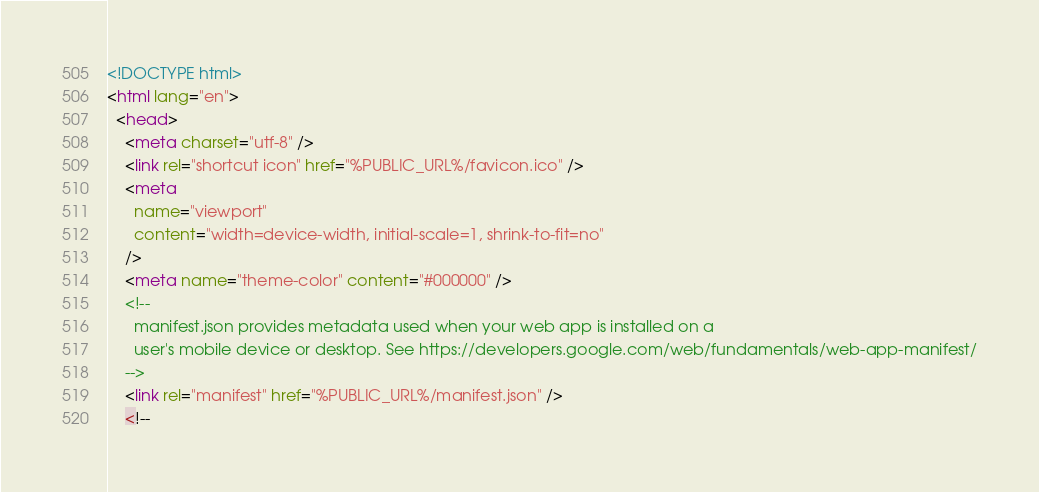<code> <loc_0><loc_0><loc_500><loc_500><_HTML_><!DOCTYPE html>
<html lang="en">
  <head>
    <meta charset="utf-8" />
    <link rel="shortcut icon" href="%PUBLIC_URL%/favicon.ico" />
    <meta
      name="viewport"
      content="width=device-width, initial-scale=1, shrink-to-fit=no"
    />
    <meta name="theme-color" content="#000000" />
    <!--
      manifest.json provides metadata used when your web app is installed on a
      user's mobile device or desktop. See https://developers.google.com/web/fundamentals/web-app-manifest/
    -->
    <link rel="manifest" href="%PUBLIC_URL%/manifest.json" />
    <!--</code> 